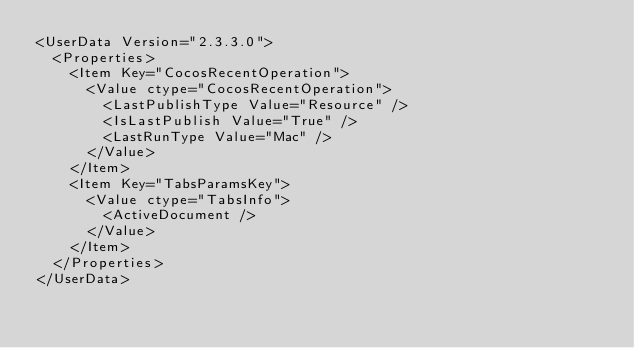<code> <loc_0><loc_0><loc_500><loc_500><_SQL_><UserData Version="2.3.3.0">
  <Properties>
    <Item Key="CocosRecentOperation">
      <Value ctype="CocosRecentOperation">
        <LastPublishType Value="Resource" />
        <IsLastPublish Value="True" />
        <LastRunType Value="Mac" />
      </Value>
    </Item>
    <Item Key="TabsParamsKey">
      <Value ctype="TabsInfo">
        <ActiveDocument />
      </Value>
    </Item>
  </Properties>
</UserData></code> 